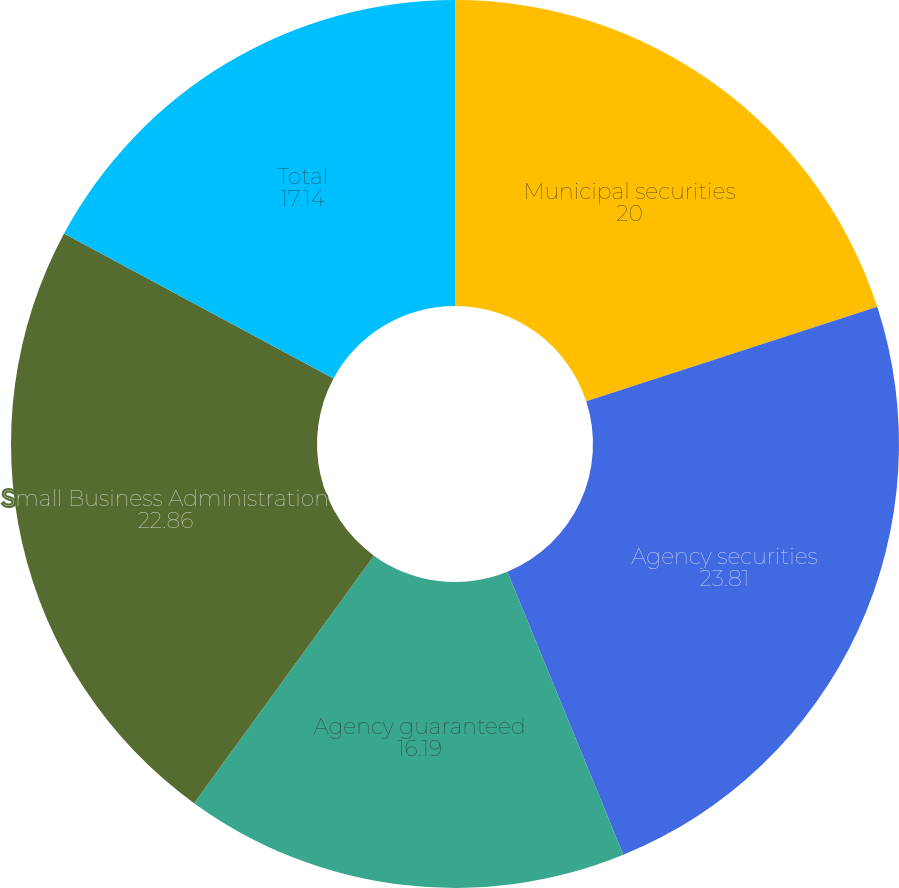Convert chart to OTSL. <chart><loc_0><loc_0><loc_500><loc_500><pie_chart><fcel>Municipal securities<fcel>Agency securities<fcel>Agency guaranteed<fcel>Small Business Administration<fcel>Total<nl><fcel>20.0%<fcel>23.81%<fcel>16.19%<fcel>22.86%<fcel>17.14%<nl></chart> 